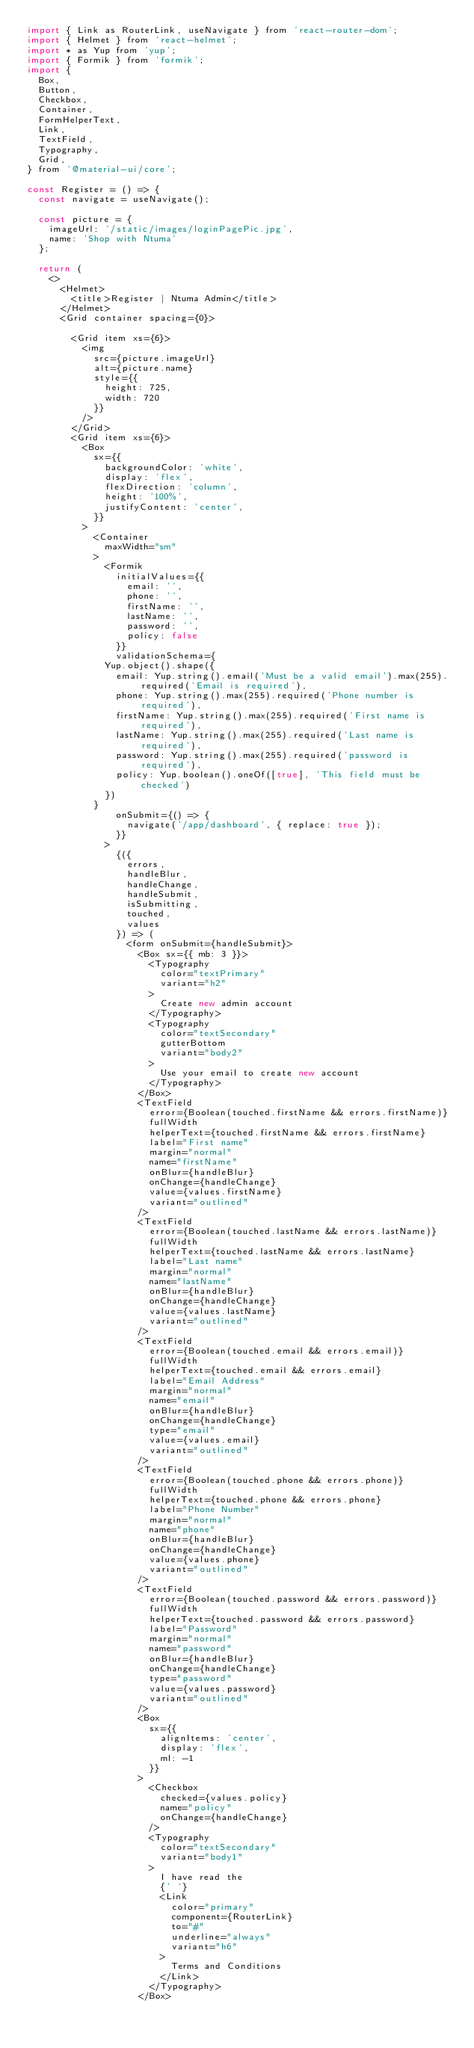Convert code to text. <code><loc_0><loc_0><loc_500><loc_500><_JavaScript_>import { Link as RouterLink, useNavigate } from 'react-router-dom';
import { Helmet } from 'react-helmet';
import * as Yup from 'yup';
import { Formik } from 'formik';
import {
  Box,
  Button,
  Checkbox,
  Container,
  FormHelperText,
  Link,
  TextField,
  Typography,
  Grid,
} from '@material-ui/core';

const Register = () => {
  const navigate = useNavigate();

  const picture = {
    imageUrl: '/static/images/loginPagePic.jpg',
    name: 'Shop with Ntuma'
  };

  return (
    <>
      <Helmet>
        <title>Register | Ntuma Admin</title>
      </Helmet>
      <Grid container spacing={0}>

        <Grid item xs={6}>
          <img
            src={picture.imageUrl}
            alt={picture.name}
            style={{
              height: 725,
              width: 720
            }}
          />
        </Grid>
        <Grid item xs={6}>
          <Box
            sx={{
              backgroundColor: 'white',
              display: 'flex',
              flexDirection: 'column',
              height: '100%',
              justifyContent: 'center',
            }}
          >
            <Container
              maxWidth="sm"
            >
              <Formik
                initialValues={{
                  email: '',
                  phone: '',
                  firstName: '',
                  lastName: '',
                  password: '',
                  policy: false
                }}
                validationSchema={
              Yup.object().shape({
                email: Yup.string().email('Must be a valid email').max(255).required('Email is required'),
                phone: Yup.string().max(255).required('Phone number is required'),
                firstName: Yup.string().max(255).required('First name is required'),
                lastName: Yup.string().max(255).required('Last name is required'),
                password: Yup.string().max(255).required('password is required'),
                policy: Yup.boolean().oneOf([true], 'This field must be checked')
              })
            }
                onSubmit={() => {
                  navigate('/app/dashboard', { replace: true });
                }}
              >
                {({
                  errors,
                  handleBlur,
                  handleChange,
                  handleSubmit,
                  isSubmitting,
                  touched,
                  values
                }) => (
                  <form onSubmit={handleSubmit}>
                    <Box sx={{ mb: 3 }}>
                      <Typography
                        color="textPrimary"
                        variant="h2"
                      >
                        Create new admin account
                      </Typography>
                      <Typography
                        color="textSecondary"
                        gutterBottom
                        variant="body2"
                      >
                        Use your email to create new account
                      </Typography>
                    </Box>
                    <TextField
                      error={Boolean(touched.firstName && errors.firstName)}
                      fullWidth
                      helperText={touched.firstName && errors.firstName}
                      label="First name"
                      margin="normal"
                      name="firstName"
                      onBlur={handleBlur}
                      onChange={handleChange}
                      value={values.firstName}
                      variant="outlined"
                    />
                    <TextField
                      error={Boolean(touched.lastName && errors.lastName)}
                      fullWidth
                      helperText={touched.lastName && errors.lastName}
                      label="Last name"
                      margin="normal"
                      name="lastName"
                      onBlur={handleBlur}
                      onChange={handleChange}
                      value={values.lastName}
                      variant="outlined"
                    />
                    <TextField
                      error={Boolean(touched.email && errors.email)}
                      fullWidth
                      helperText={touched.email && errors.email}
                      label="Email Address"
                      margin="normal"
                      name="email"
                      onBlur={handleBlur}
                      onChange={handleChange}
                      type="email"
                      value={values.email}
                      variant="outlined"
                    />
                    <TextField
                      error={Boolean(touched.phone && errors.phone)}
                      fullWidth
                      helperText={touched.phone && errors.phone}
                      label="Phone Number"
                      margin="normal"
                      name="phone"
                      onBlur={handleBlur}
                      onChange={handleChange}
                      value={values.phone}
                      variant="outlined"
                    />
                    <TextField
                      error={Boolean(touched.password && errors.password)}
                      fullWidth
                      helperText={touched.password && errors.password}
                      label="Password"
                      margin="normal"
                      name="password"
                      onBlur={handleBlur}
                      onChange={handleChange}
                      type="password"
                      value={values.password}
                      variant="outlined"
                    />
                    <Box
                      sx={{
                        alignItems: 'center',
                        display: 'flex',
                        ml: -1
                      }}
                    >
                      <Checkbox
                        checked={values.policy}
                        name="policy"
                        onChange={handleChange}
                      />
                      <Typography
                        color="textSecondary"
                        variant="body1"
                      >
                        I have read the
                        {' '}
                        <Link
                          color="primary"
                          component={RouterLink}
                          to="#"
                          underline="always"
                          variant="h6"
                        >
                          Terms and Conditions
                        </Link>
                      </Typography>
                    </Box></code> 